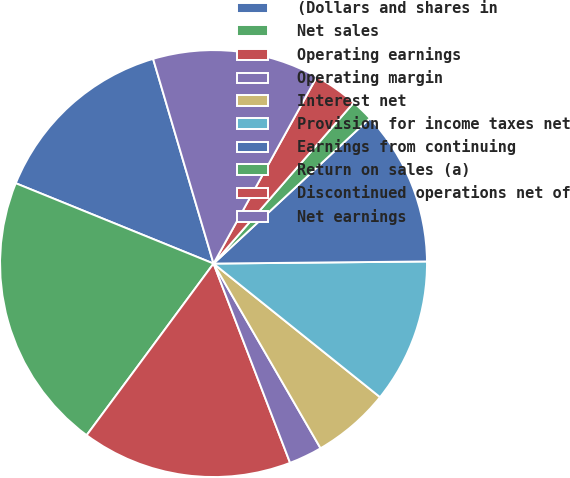<chart> <loc_0><loc_0><loc_500><loc_500><pie_chart><fcel>(Dollars and shares in<fcel>Net sales<fcel>Operating earnings<fcel>Operating margin<fcel>Interest net<fcel>Provision for income taxes net<fcel>Earnings from continuing<fcel>Return on sales (a)<fcel>Discontinued operations net of<fcel>Net earnings<nl><fcel>14.29%<fcel>21.01%<fcel>15.97%<fcel>2.52%<fcel>5.88%<fcel>10.92%<fcel>11.76%<fcel>1.68%<fcel>3.36%<fcel>12.61%<nl></chart> 